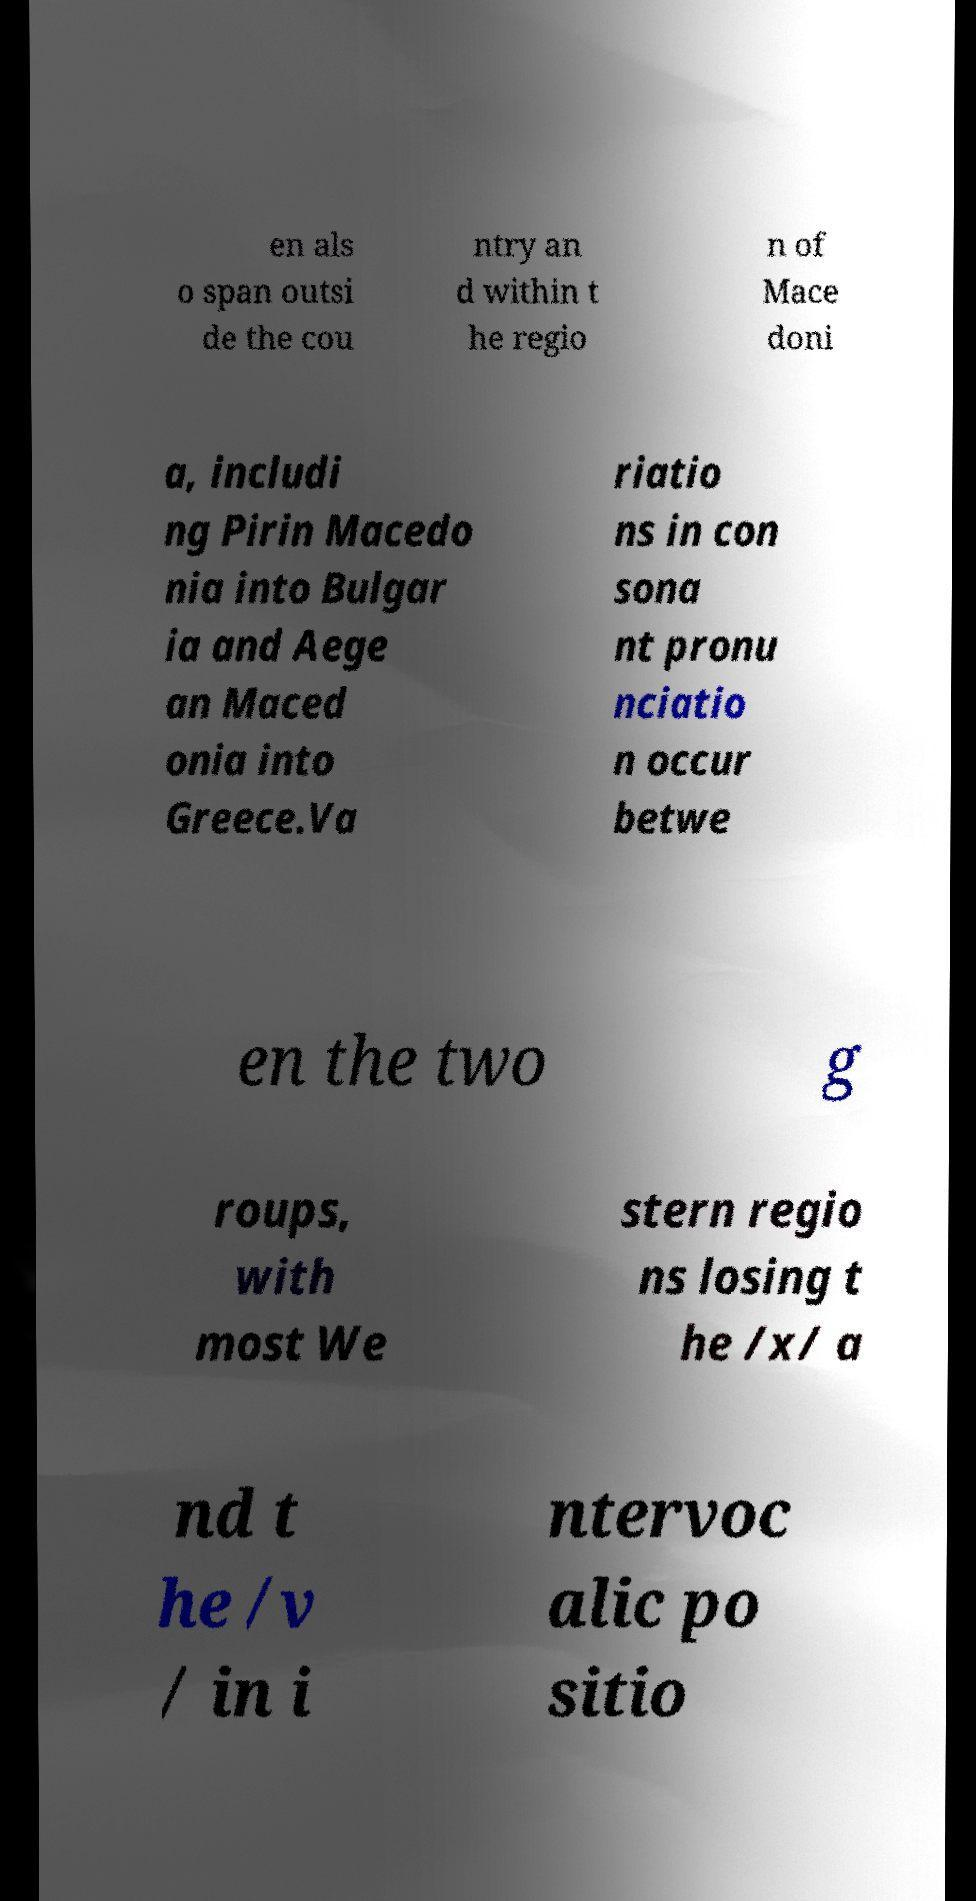For documentation purposes, I need the text within this image transcribed. Could you provide that? en als o span outsi de the cou ntry an d within t he regio n of Mace doni a, includi ng Pirin Macedo nia into Bulgar ia and Aege an Maced onia into Greece.Va riatio ns in con sona nt pronu nciatio n occur betwe en the two g roups, with most We stern regio ns losing t he /x/ a nd t he /v / in i ntervoc alic po sitio 